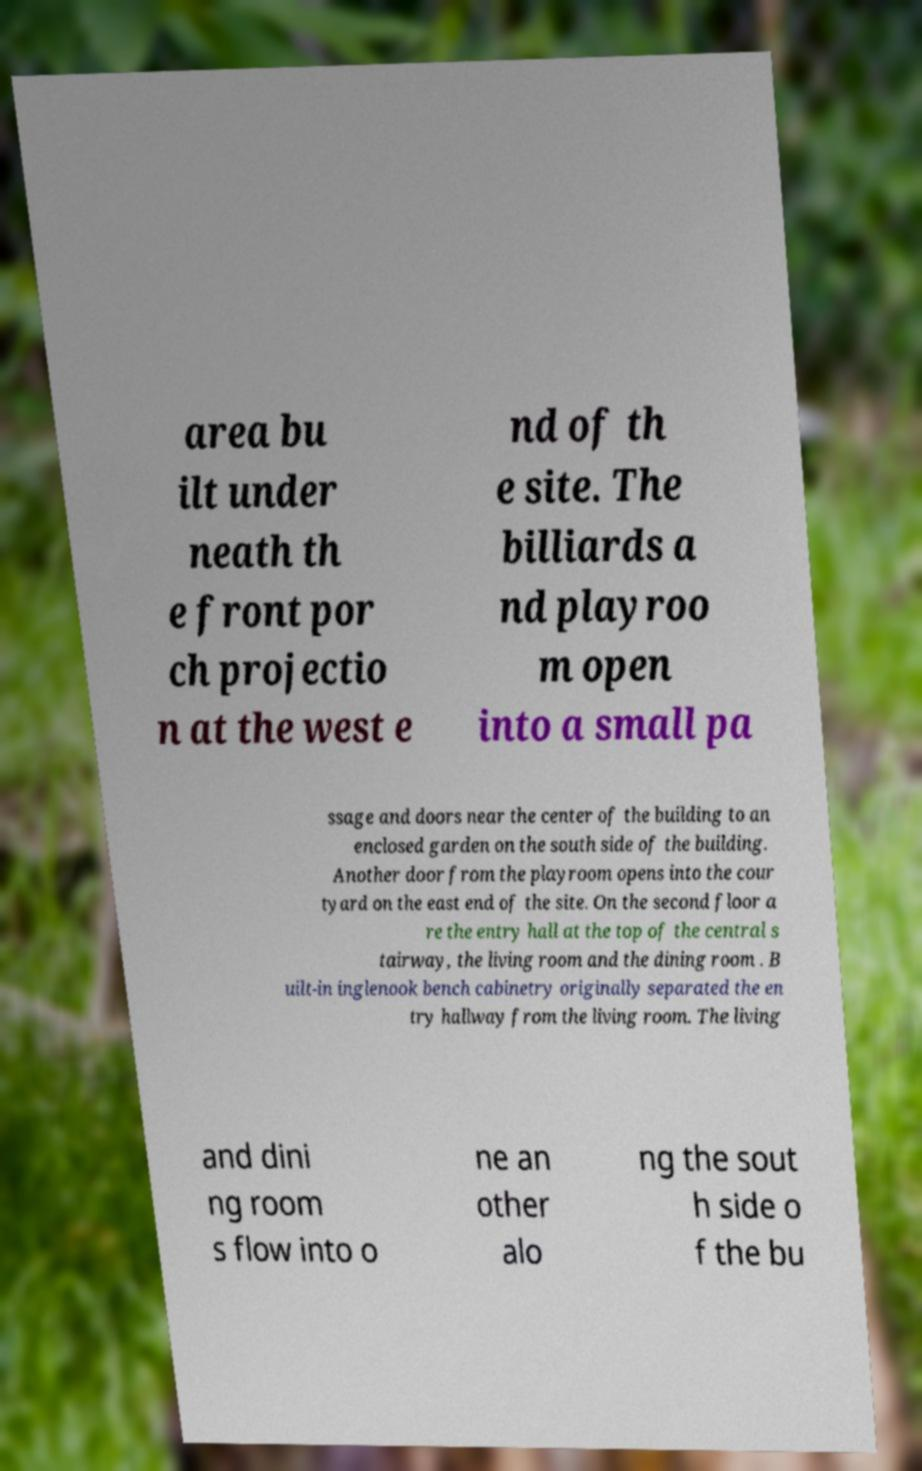Please read and relay the text visible in this image. What does it say? area bu ilt under neath th e front por ch projectio n at the west e nd of th e site. The billiards a nd playroo m open into a small pa ssage and doors near the center of the building to an enclosed garden on the south side of the building. Another door from the playroom opens into the cour tyard on the east end of the site. On the second floor a re the entry hall at the top of the central s tairway, the living room and the dining room . B uilt-in inglenook bench cabinetry originally separated the en try hallway from the living room. The living and dini ng room s flow into o ne an other alo ng the sout h side o f the bu 